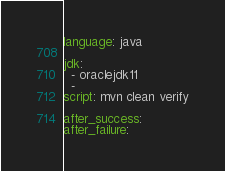<code> <loc_0><loc_0><loc_500><loc_500><_YAML_>language: java

jdk:
  - oraclejdk11
  -
script: mvn clean verify

after_success:
after_failure:</code> 